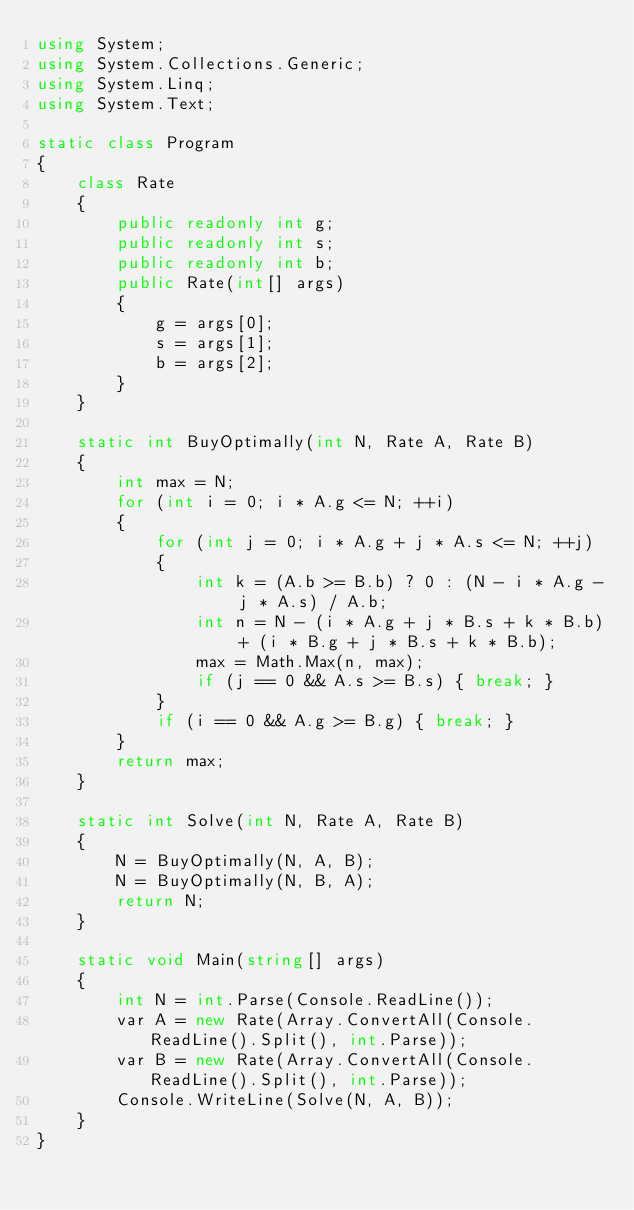<code> <loc_0><loc_0><loc_500><loc_500><_C#_>using System;
using System.Collections.Generic;
using System.Linq;
using System.Text;

static class Program
{
    class Rate
    {
        public readonly int g;
        public readonly int s;
        public readonly int b;
        public Rate(int[] args)
        {
            g = args[0];
            s = args[1];
            b = args[2];
        }
    }

    static int BuyOptimally(int N, Rate A, Rate B)
    {
        int max = N;
        for (int i = 0; i * A.g <= N; ++i)
        {
            for (int j = 0; i * A.g + j * A.s <= N; ++j)
            {
                int k = (A.b >= B.b) ? 0 : (N - i * A.g - j * A.s) / A.b;
                int n = N - (i * A.g + j * B.s + k * B.b) + (i * B.g + j * B.s + k * B.b);
                max = Math.Max(n, max);
                if (j == 0 && A.s >= B.s) { break; }
            }
            if (i == 0 && A.g >= B.g) { break; }
        }
        return max;
    }

    static int Solve(int N, Rate A, Rate B)
    {
        N = BuyOptimally(N, A, B);
        N = BuyOptimally(N, B, A);
        return N;
    }

    static void Main(string[] args)
    {
        int N = int.Parse(Console.ReadLine());
        var A = new Rate(Array.ConvertAll(Console.ReadLine().Split(), int.Parse));
        var B = new Rate(Array.ConvertAll(Console.ReadLine().Split(), int.Parse));
        Console.WriteLine(Solve(N, A, B));
    }
}
</code> 